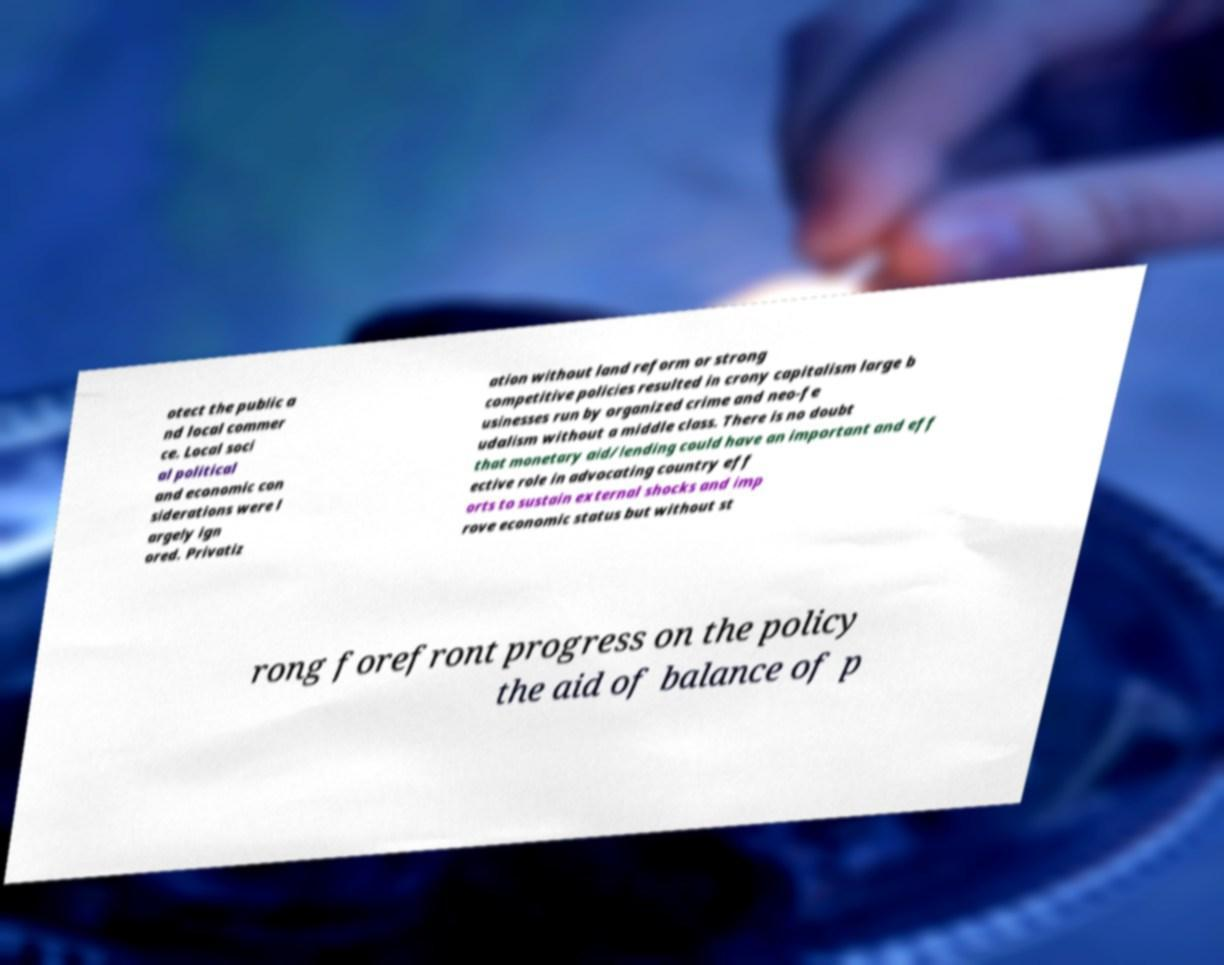Can you read and provide the text displayed in the image?This photo seems to have some interesting text. Can you extract and type it out for me? otect the public a nd local commer ce. Local soci al political and economic con siderations were l argely ign ored. Privatiz ation without land reform or strong competitive policies resulted in crony capitalism large b usinesses run by organized crime and neo-fe udalism without a middle class. There is no doubt that monetary aid/lending could have an important and eff ective role in advocating country eff orts to sustain external shocks and imp rove economic status but without st rong forefront progress on the policy the aid of balance of p 